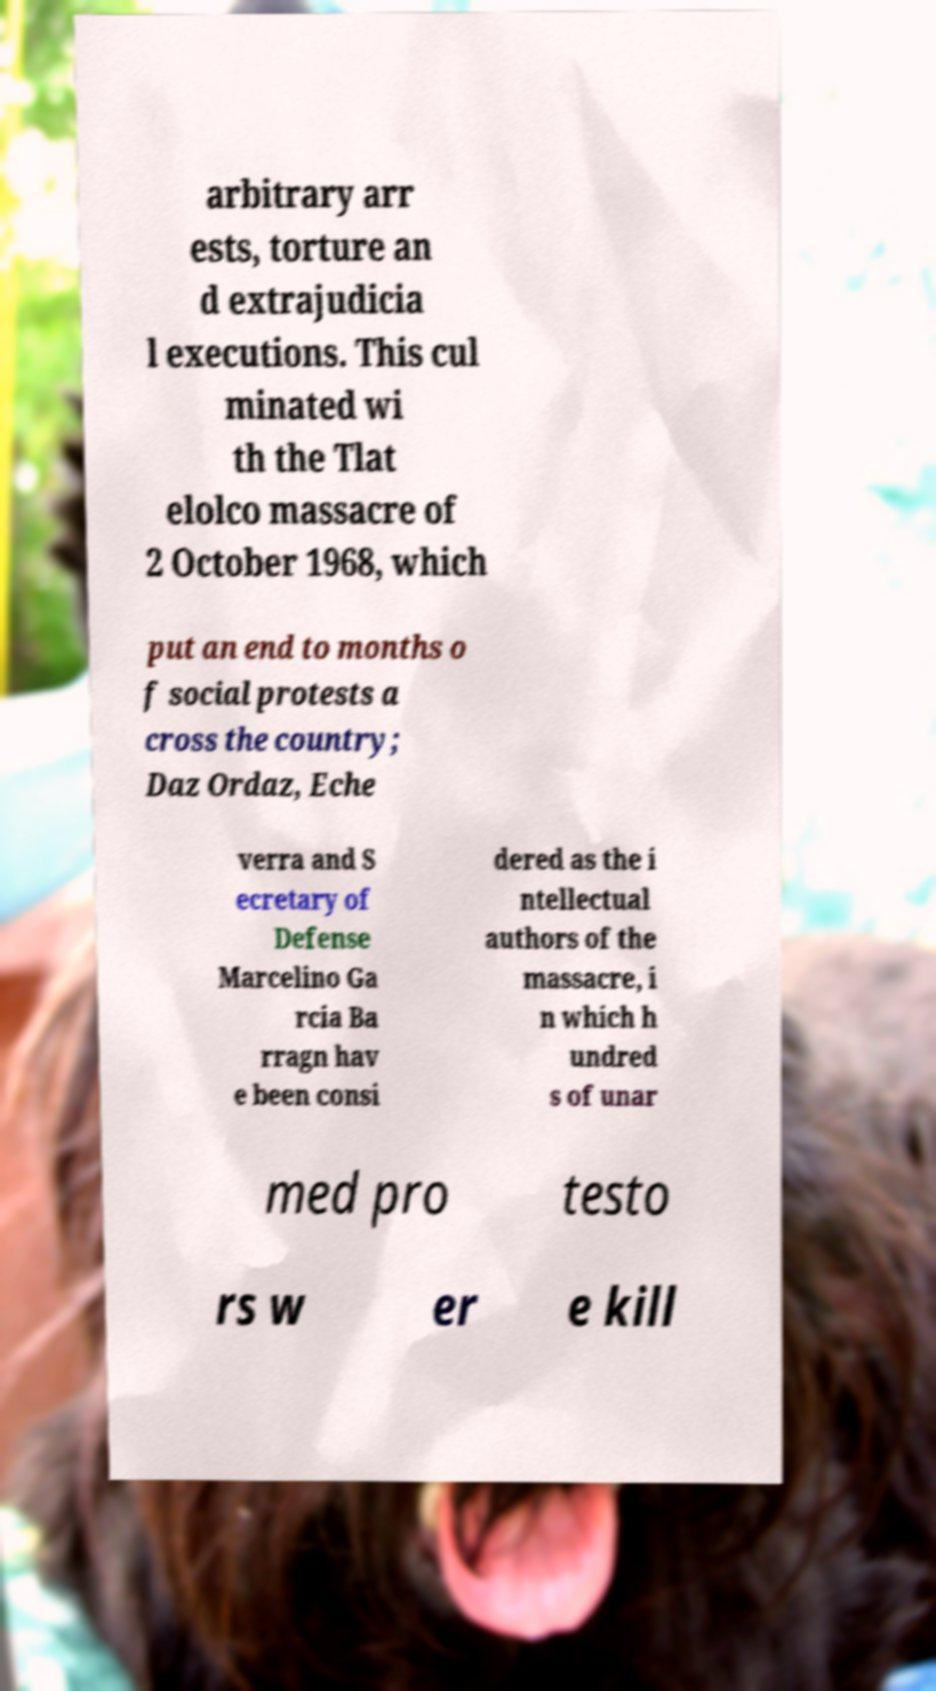Please read and relay the text visible in this image. What does it say? arbitrary arr ests, torture an d extrajudicia l executions. This cul minated wi th the Tlat elolco massacre of 2 October 1968, which put an end to months o f social protests a cross the country; Daz Ordaz, Eche verra and S ecretary of Defense Marcelino Ga rcia Ba rragn hav e been consi dered as the i ntellectual authors of the massacre, i n which h undred s of unar med pro testo rs w er e kill 